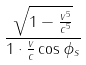<formula> <loc_0><loc_0><loc_500><loc_500>\frac { \sqrt { 1 - \frac { v ^ { 5 } } { c ^ { 5 } } } } { 1 \cdot \frac { v } { c } \cos \phi _ { s } }</formula> 